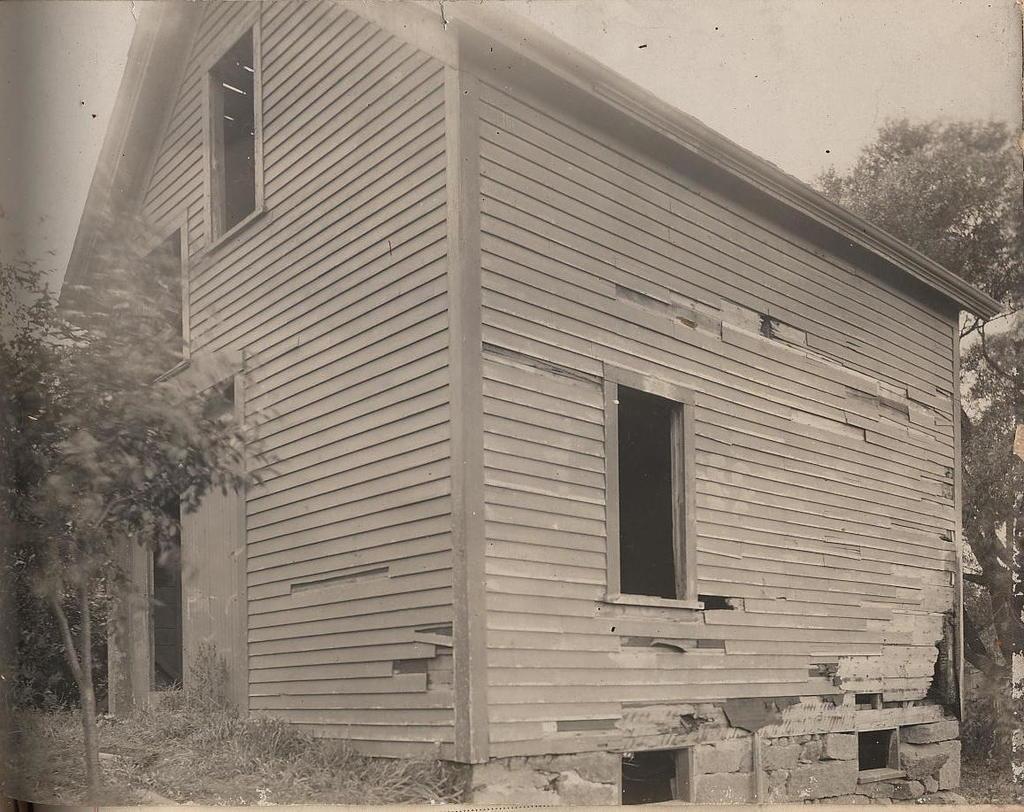Can you describe this image briefly? In this image there is a house. Left side there are few plants and trees are on the grassland. Right side there is a tree. Top of the image there is sky. 